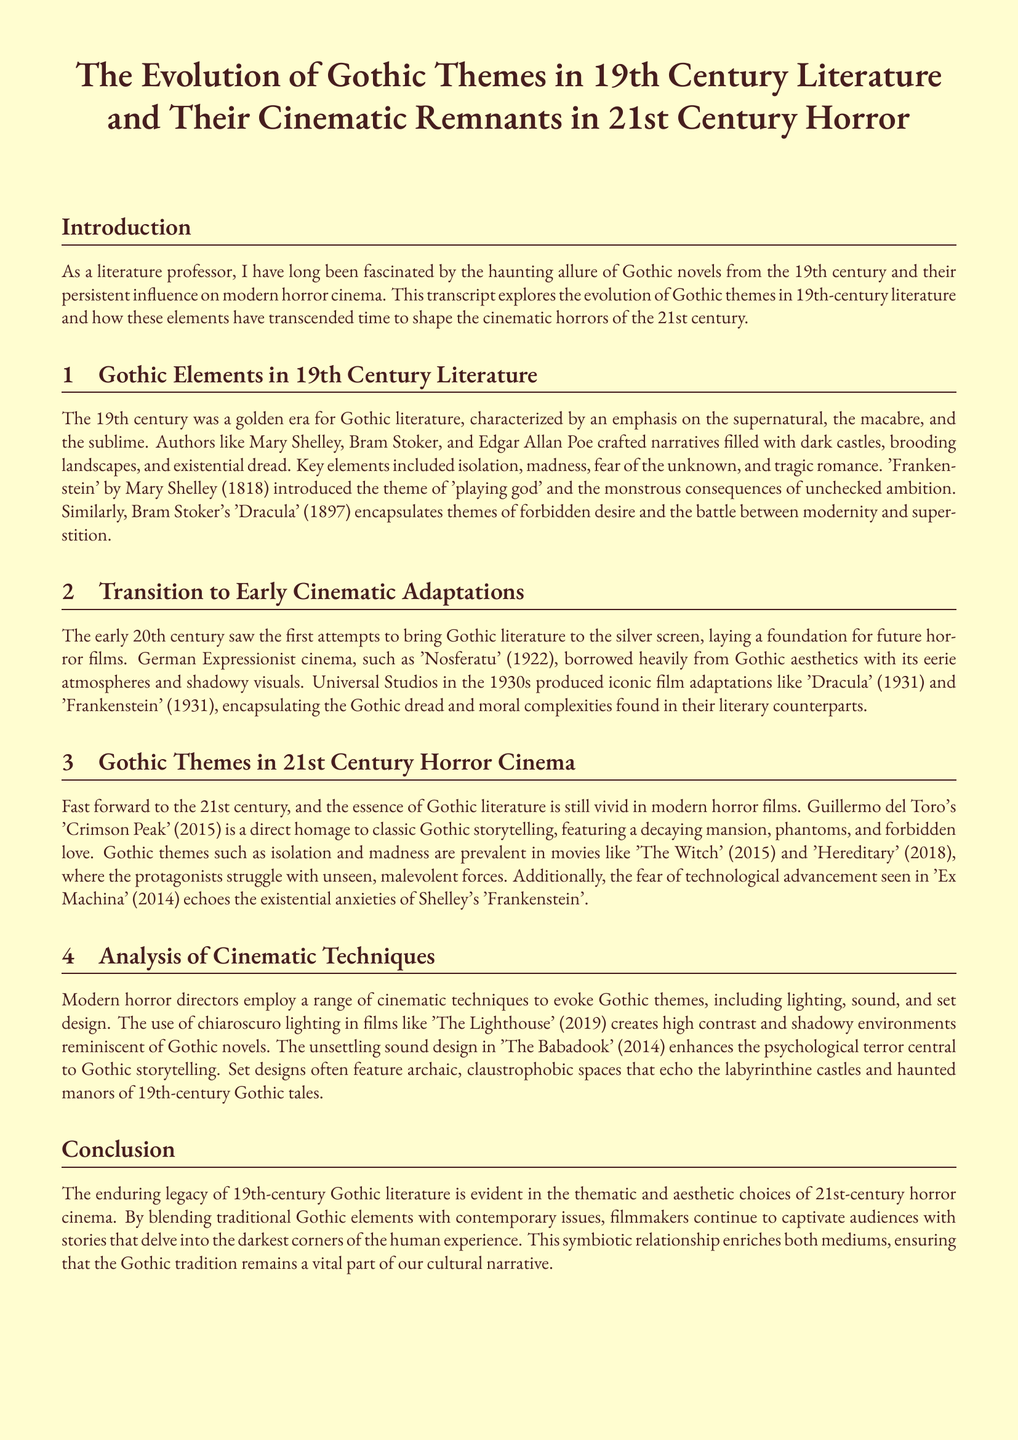What is the title of the document? The title is explicitly stated at the beginning of the transcript, which describes the subject being explored.
Answer: The Evolution of Gothic Themes in 19th Century Literature and Their Cinematic Remnants in 21st Century Horror Who wrote 'Frankenstein'? The document names Mary Shelley as the author of 'Frankenstein', highlighting her contribution to Gothic literature.
Answer: Mary Shelley What year was 'Dracula' published? The document specifies the publication year of 'Dracula' as part of the discussion on Gothic literature.
Answer: 1897 Which film is a direct homage to classic Gothic storytelling? The document mentions 'Crimson Peak' as a notable example of modern cinema that honors Gothic narrative tradition.
Answer: Crimson Peak What cinematic technique is commonly used to evoke Gothic themes? The document discusses lighting as a significant cinematic technique that enhances the Gothic atmosphere in films.
Answer: Chiaroscuro lighting How many iconic film adaptations did Universal Studios produce in the 1930s? The document hints at multiple adaptations without giving a specific number, requiring inference from the surrounding context.
Answer: Two What theme is prevalent in 'The Witch'? The discussion includes themes such as isolation and madness, highlighting their relevance in contemporary horror cinema.
Answer: Isolation Which two films were mentioned as examples of modern horror that reflect Gothic themes? The document lists 'The Witch' and 'Hereditary' within the context of modern film reflecting traditional Gothic themes.
Answer: The Witch and Hereditary What literary theme does 'Ex Machina' echo? The connection drawn between 'Ex Machina' and the ideas presented in 'Frankenstein' is a key point made in the analysis of modern horror.
Answer: Fear of technological advancement 